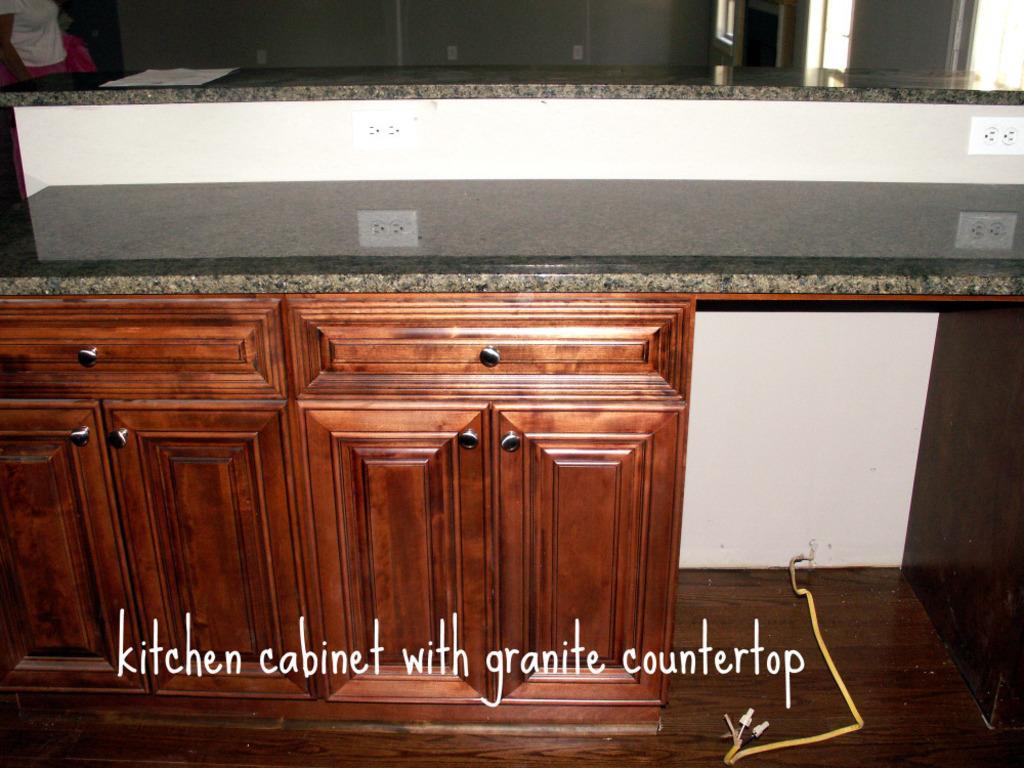Please provide a concise description of this image. In the picture we can see some wooden cupboards and beside it we can see a white plank and on the top of it we can see a plank with some switch socket to it. 